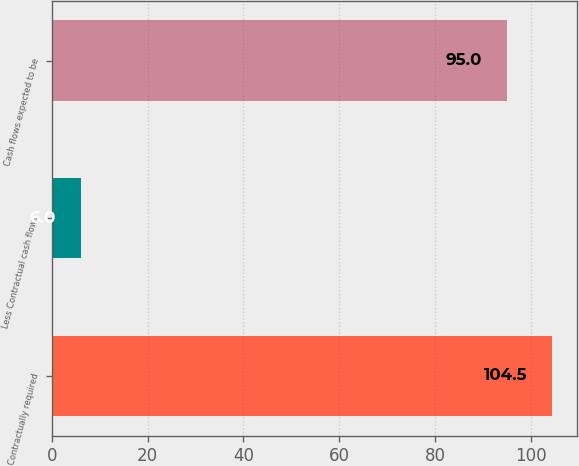Convert chart to OTSL. <chart><loc_0><loc_0><loc_500><loc_500><bar_chart><fcel>Contractually required<fcel>Less Contractual cash flows<fcel>Cash flows expected to be<nl><fcel>104.5<fcel>6<fcel>95<nl></chart> 